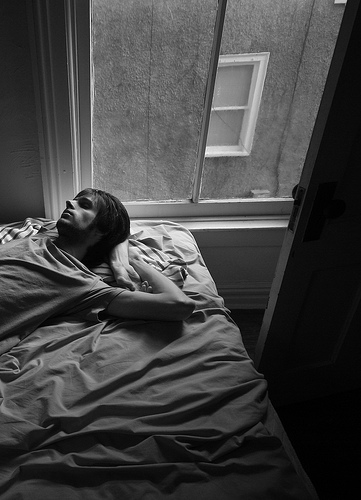What is the guy of the bed doing? The guy is lying in the bed. 